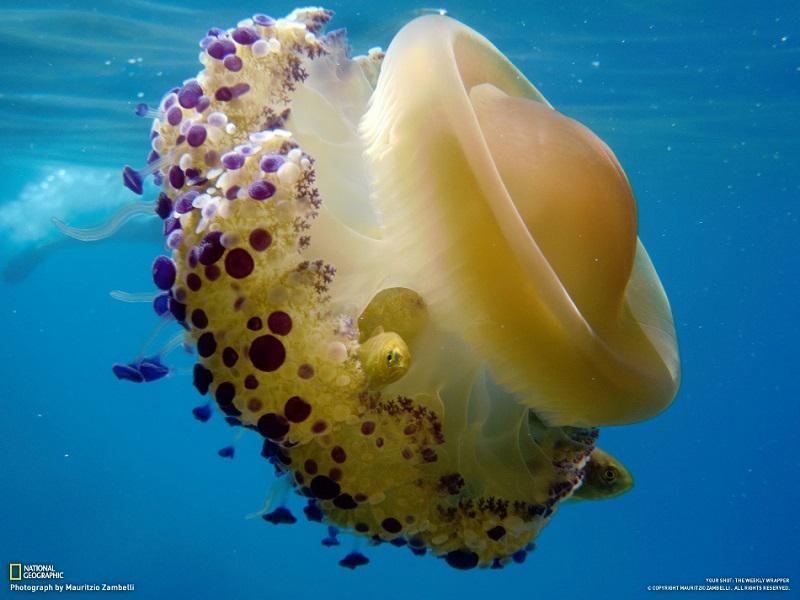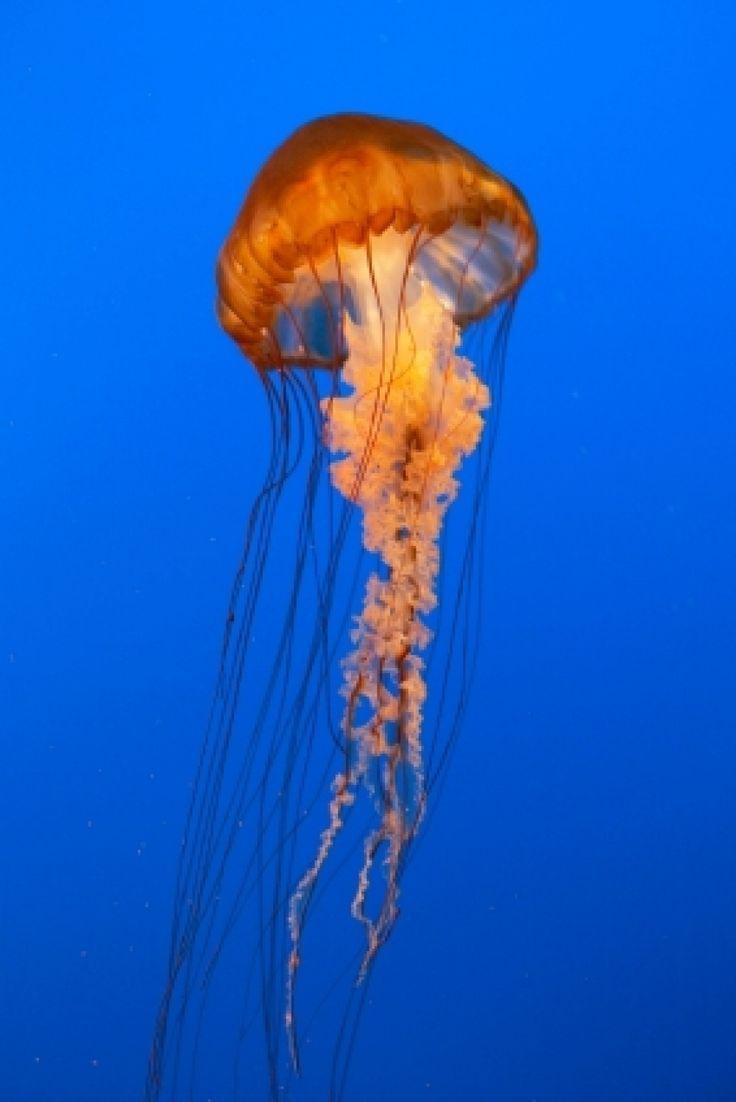The first image is the image on the left, the second image is the image on the right. Assess this claim about the two images: "At least one image shows one orange jellyfish with frilly tendrils hanging down between stringlike ones.". Correct or not? Answer yes or no. Yes. 